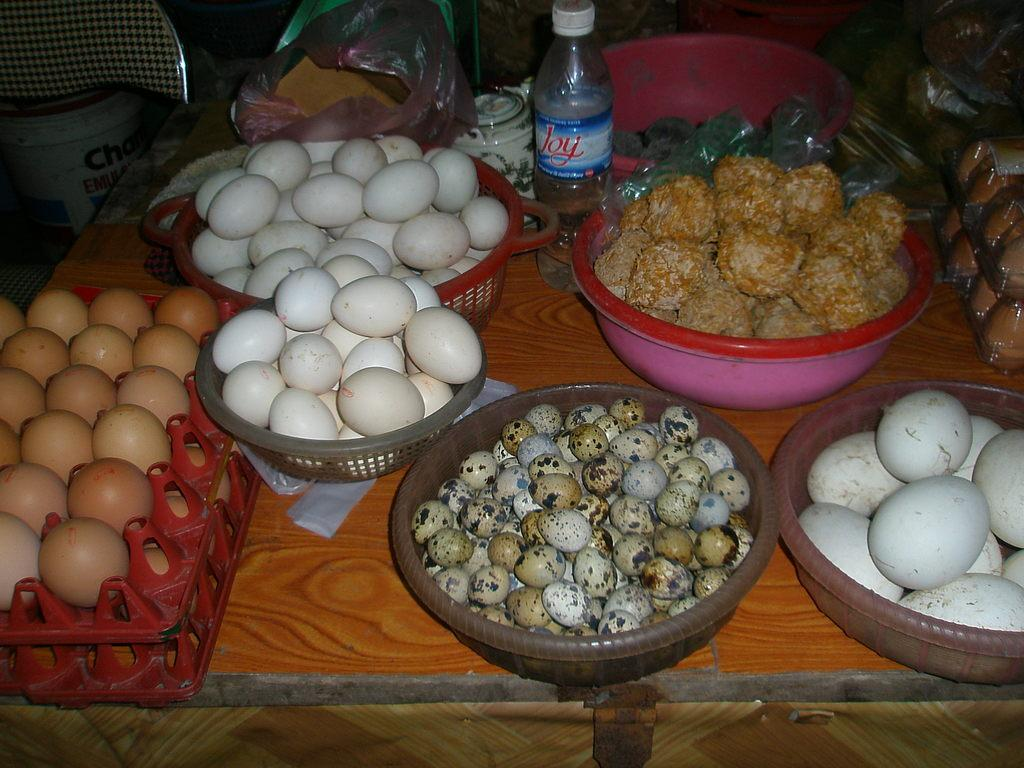What objects are on the table in the image? There are bowls, eggs, and a bottle on the table in the image. What might be contained in the bowls? The contents of the bowls are not visible in the image, so it cannot be determined what they contain. What is the shape of the bottle on the table? The shape of the bottle on the table is not visible in the image, so it cannot be determined. Can you see a hose on the street in the image? There is no street or hose present in the image; it only shows objects on a table. 